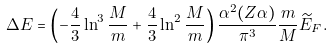<formula> <loc_0><loc_0><loc_500><loc_500>\Delta E = \left ( - \frac { 4 } { 3 } \ln ^ { 3 } \frac { M } { m } + \frac { 4 } { 3 } \ln ^ { 2 } \frac { M } { m } \right ) \frac { \alpha ^ { 2 } ( Z \alpha ) } { \pi ^ { 3 } } \frac { m } { M } { \widetilde { E } } _ { F } .</formula> 